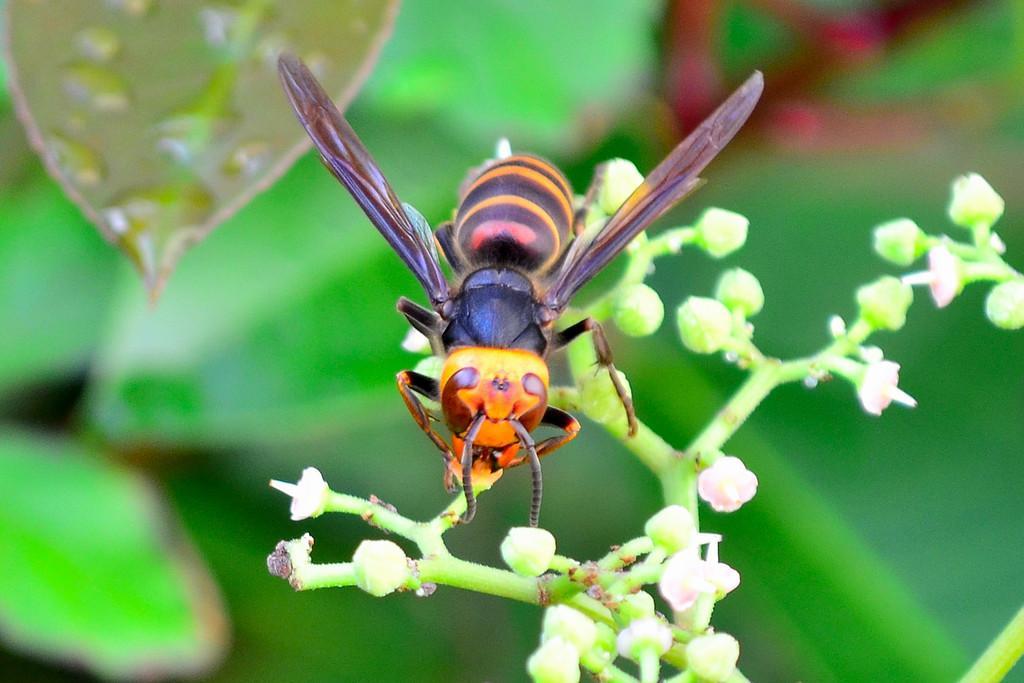Please provide a concise description of this image. In the middle of this image, there is an insect on a plant. On the top left, there are water drops on a leaf. And the background is blurred. 